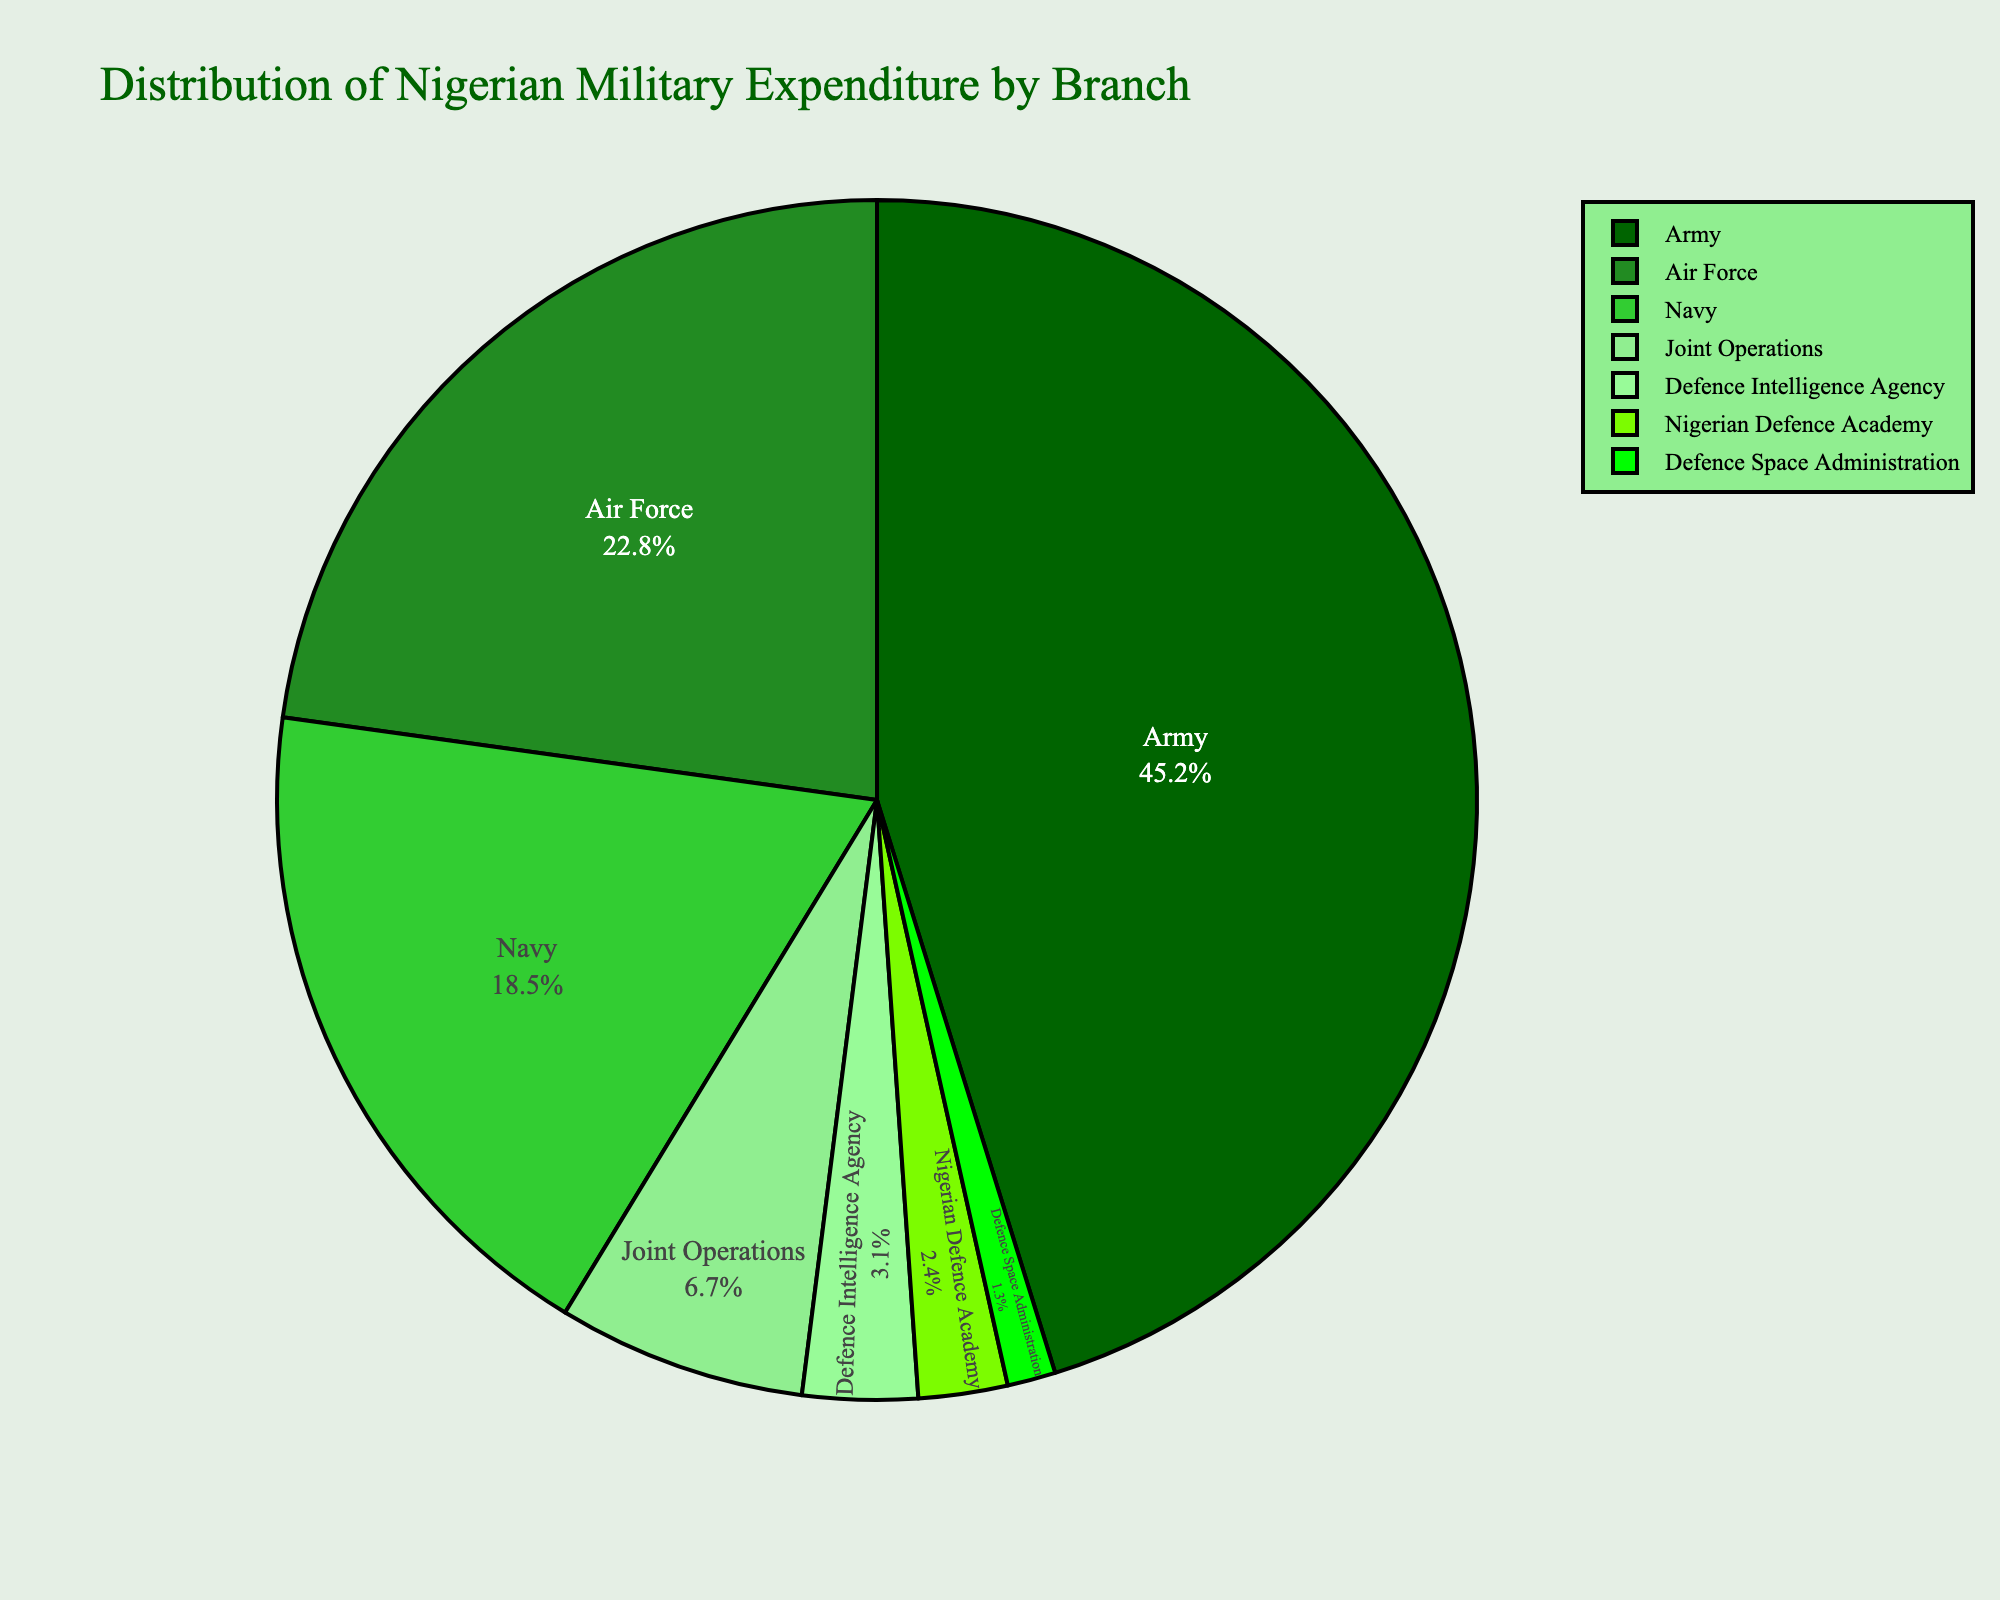What's the largest expenditure by branch? The largest slice of the pie chart will indicate the branch with the highest percentage. From the chart, the Army's expenditure is 45.2%, which is the largest figure among all listed branches.
Answer: Army Which branch has the smallest expenditure? By looking for the smallest slice of the pie chart, we observe that the Defence Space Administration has the smallest expenditure at 1.3%.
Answer: Defence Space Administration What is the combined expenditure percentage for the Navy and Air Force? To find the combined expenditure percentage, add the percentages for the Navy (18.5%) and the Air Force (22.8%). The sum is 18.5 + 22.8 = 41.3%.
Answer: 41.3% Is the Army's expenditure more than double that of the Nigerian Defence Academy? The Army's expenditure is 45.2%, and the Nigerian Defence Academy's expenditure is 2.4%. Doubling the Nigerian Defence Academy's percentage gives 2.4 * 2 = 4.8%. Since 45.2% > 4.8%, the Army's expenditure is indeed more than double.
Answer: Yes Which expenditure is larger: Joint Operations or Defence Intelligence Agency? By comparing their percentages, we see that Joint Operations has 6.7% and Defence Intelligence Agency has 3.1%. Thus, Joint Operations has a larger expenditure.
Answer: Joint Operations What is the percentage difference between the Navy and the Army? Subtract the Navy's expenditure percentage (18.5%) from the Army's expenditure percentage (45.2%) to get the difference: 45.2 - 18.5 = 26.7%.
Answer: 26.7% How much higher is the Air Force’s percentage compared to Joint Operations? Subtract the Joint Operations' expenditure percentage (6.7%) from the Air Force's expenditure percentage (22.8%): 22.8 - 6.7 = 16.1%.
Answer: 16.1% What is the total expenditure percentage for all branches except the Army? Exclude the Army's expenditure (45.2%) and sum up the percentages for the other branches: 22.8 (Air Force) + 18.5 (Navy) + 6.7 (Joint Operations) + 3.1 (Defence Intelligence Agency) + 2.4 (Nigerian Defence Academy) + 1.3 (Defence Space Administration) = 54.8%.
Answer: 54.8% Do the combined expenditures of the Navy and the Nigerian Defence Academy exceed that of the Air Force? Sum the expenditures of the Navy (18.5%) and the Nigerian Defence Academy (2.4%), which totals 18.5 + 2.4 = 20.9%. Since the Air Force's expenditure is 22.8%, 20.9% < 22.8%.
Answer: No From the color indicated, which branch is represented by the darkest green color? The darkest green color is assigned to the branch with the largest slice, which is the Army with 45.2%.
Answer: Army 